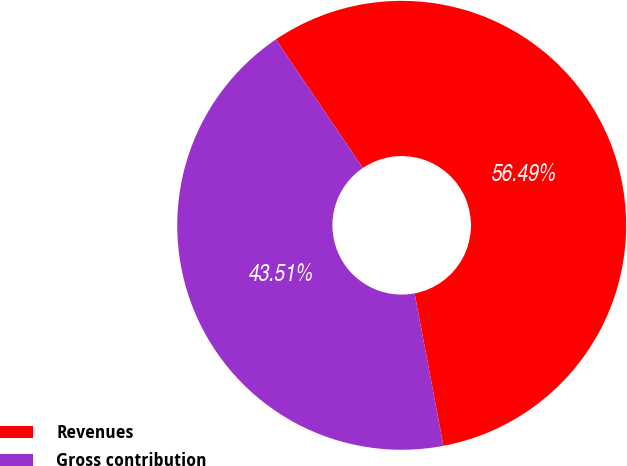Convert chart to OTSL. <chart><loc_0><loc_0><loc_500><loc_500><pie_chart><fcel>Revenues<fcel>Gross contribution<nl><fcel>56.49%<fcel>43.51%<nl></chart> 